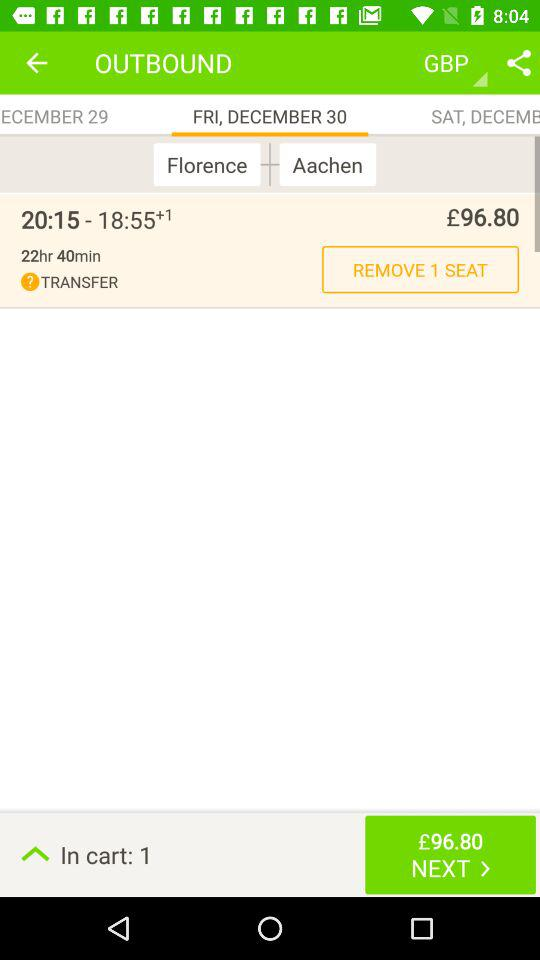For which date was the reservation done? The reservation was done for Friday, December 30. 